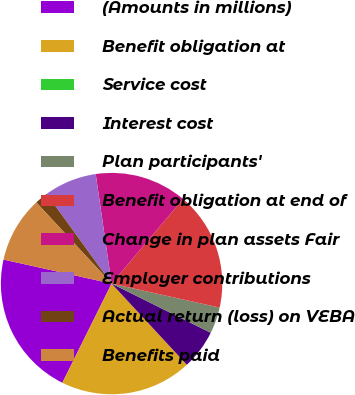Convert chart to OTSL. <chart><loc_0><loc_0><loc_500><loc_500><pie_chart><fcel>(Amounts in millions)<fcel>Benefit obligation at<fcel>Service cost<fcel>Interest cost<fcel>Plan participants'<fcel>Benefit obligation at end of<fcel>Change in plan assets Fair<fcel>Employer contributions<fcel>Actual return (loss) on VEBA<fcel>Benefits paid<nl><fcel>21.15%<fcel>19.23%<fcel>0.0%<fcel>5.77%<fcel>3.85%<fcel>17.31%<fcel>13.46%<fcel>7.69%<fcel>1.92%<fcel>9.62%<nl></chart> 